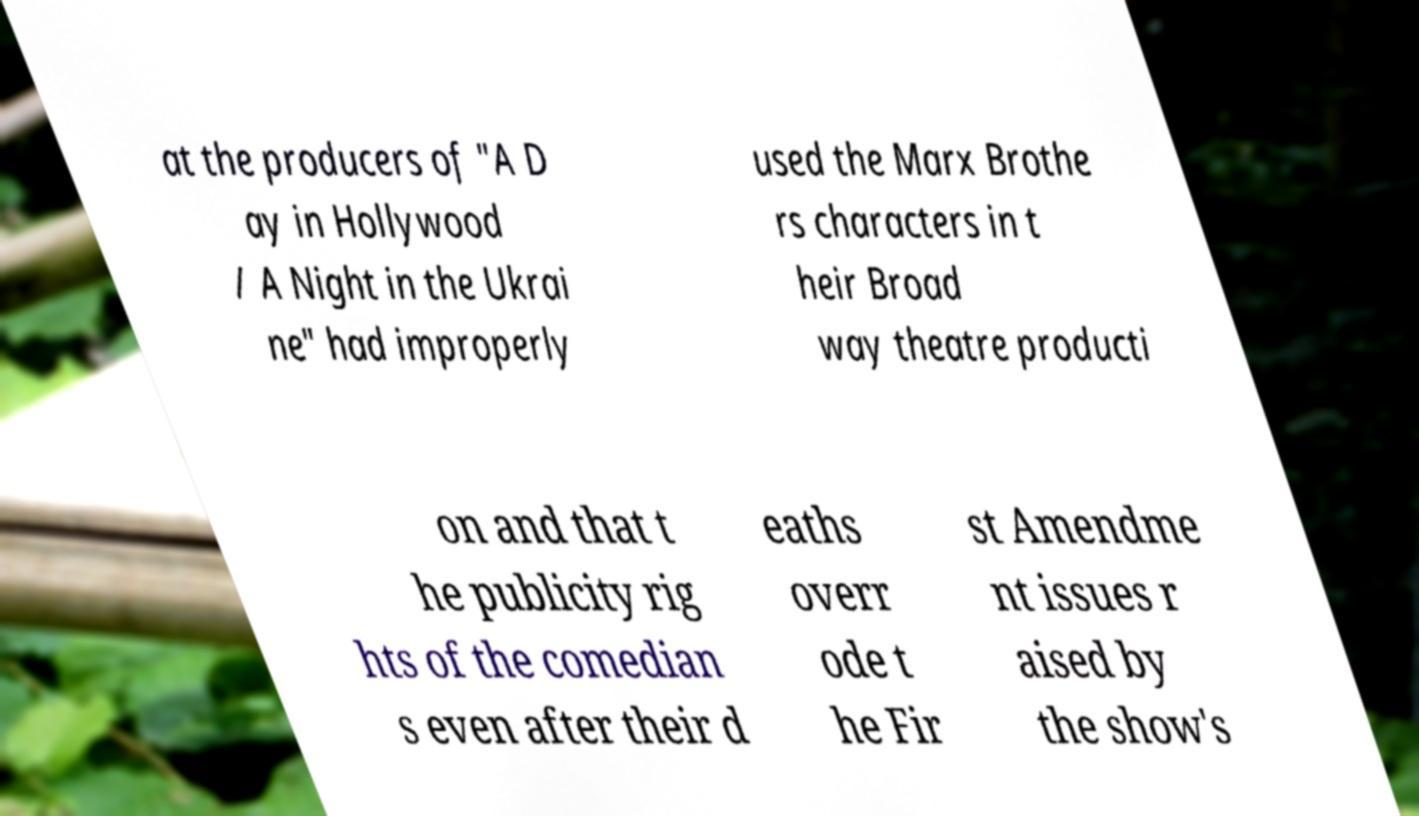Could you assist in decoding the text presented in this image and type it out clearly? at the producers of "A D ay in Hollywood / A Night in the Ukrai ne" had improperly used the Marx Brothe rs characters in t heir Broad way theatre producti on and that t he publicity rig hts of the comedian s even after their d eaths overr ode t he Fir st Amendme nt issues r aised by the show's 